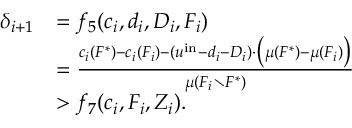<formula> <loc_0><loc_0><loc_500><loc_500>\begin{array} { r l } { \delta _ { i + 1 } } & { = f _ { 5 } ( c _ { i } , d _ { i } , D _ { i } , F _ { i } ) } & { = \frac { c _ { i } ( F ^ { * } ) - c _ { i } ( F _ { i } ) - ( u ^ { i n } - d _ { i } - D _ { i } ) \cdot \left ( \mu ( F ^ { * } ) - \mu ( F _ { i } ) \right ) } { \mu ( F _ { i } \ F ^ { * } ) } } & { > f _ { 7 } ( c _ { i } , F _ { i } , Z _ { i } ) . } \end{array}</formula> 